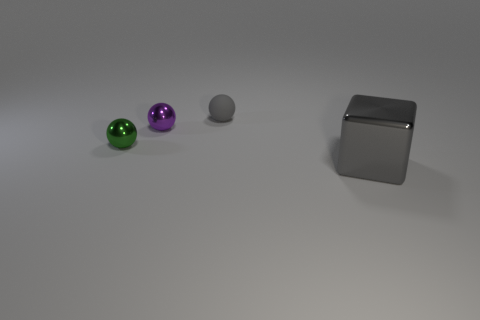Is there anything else that has the same size as the gray shiny cube?
Make the answer very short. No. What shape is the other object that is the same color as the big thing?
Your answer should be very brief. Sphere. What color is the metal thing to the right of the gray object on the left side of the gray object that is in front of the small gray rubber sphere?
Your answer should be very brief. Gray. There is a metal thing that is both in front of the purple shiny sphere and behind the big gray cube; how big is it?
Your answer should be very brief. Small. How many other objects are the same shape as the gray metallic object?
Your answer should be very brief. 0. What number of cubes are small purple things or big objects?
Make the answer very short. 1. Is there a small matte ball that is left of the gray object on the right side of the gray object on the left side of the gray cube?
Provide a succinct answer. Yes. There is another tiny shiny thing that is the same shape as the tiny green thing; what color is it?
Make the answer very short. Purple. What number of brown things are small shiny spheres or rubber things?
Ensure brevity in your answer.  0. What material is the gray thing that is in front of the gray thing behind the large metallic block?
Your answer should be compact. Metal. 